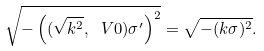Convert formula to latex. <formula><loc_0><loc_0><loc_500><loc_500>\sqrt { - \left ( ( \sqrt { k ^ { 2 } } , \ V 0 ) \sigma ^ { \prime } \right ) ^ { 2 } } = \sqrt { - ( k \sigma ) ^ { 2 } } .</formula> 